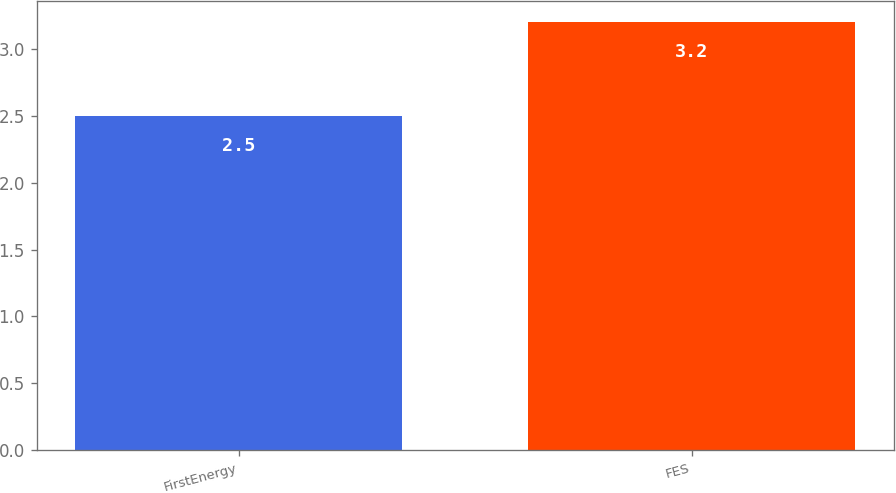<chart> <loc_0><loc_0><loc_500><loc_500><bar_chart><fcel>FirstEnergy<fcel>FES<nl><fcel>2.5<fcel>3.2<nl></chart> 